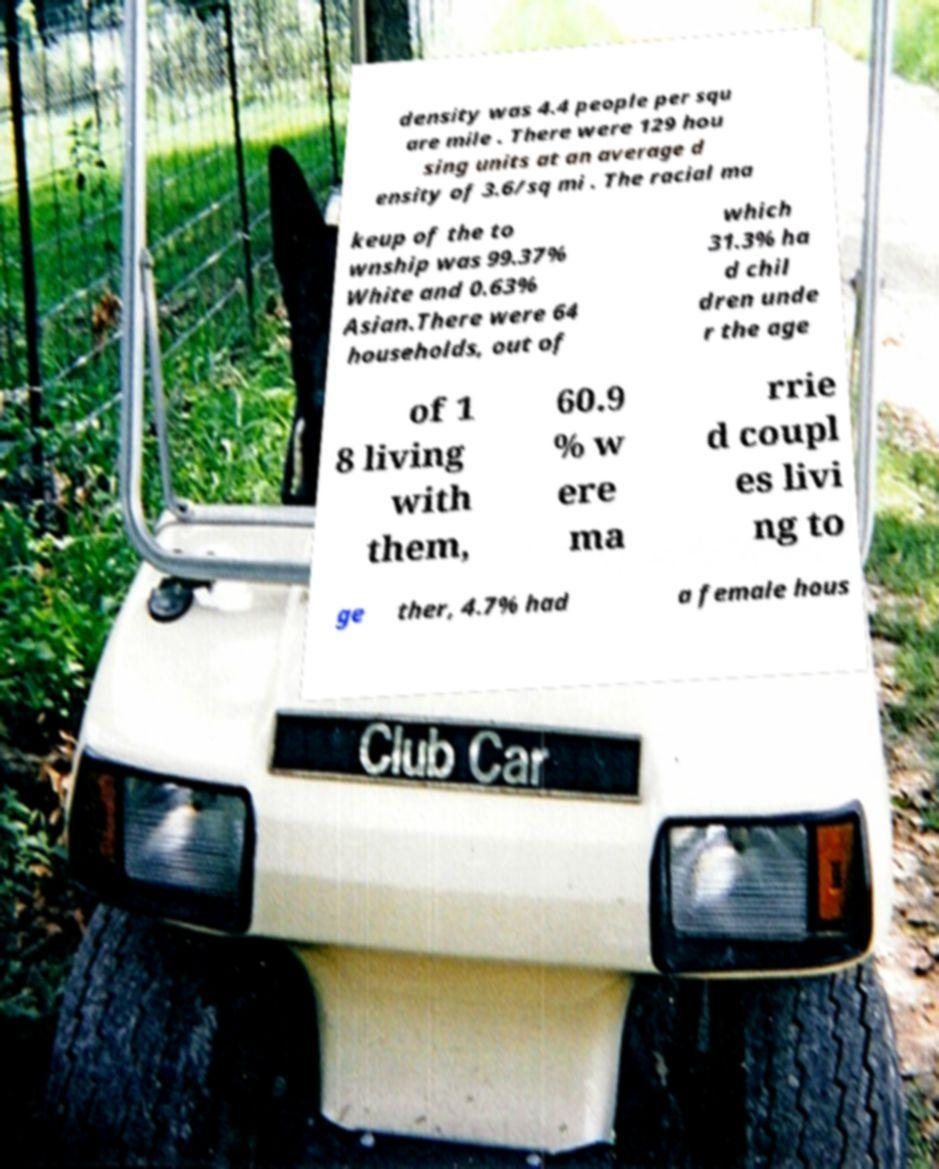Could you extract and type out the text from this image? density was 4.4 people per squ are mile . There were 129 hou sing units at an average d ensity of 3.6/sq mi . The racial ma keup of the to wnship was 99.37% White and 0.63% Asian.There were 64 households, out of which 31.3% ha d chil dren unde r the age of 1 8 living with them, 60.9 % w ere ma rrie d coupl es livi ng to ge ther, 4.7% had a female hous 